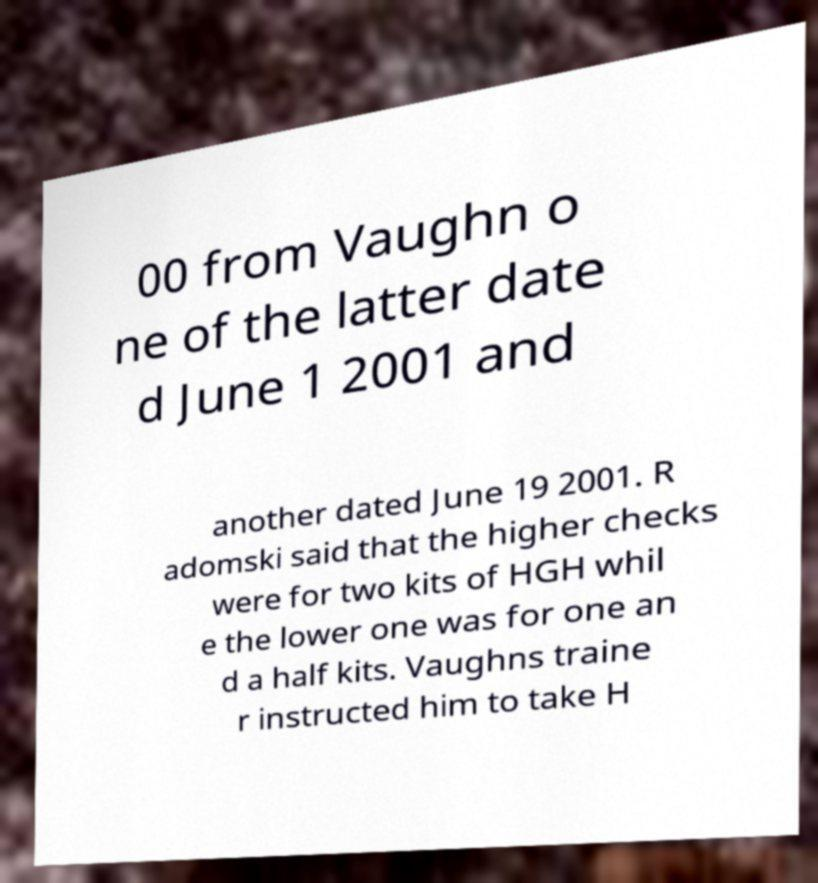I need the written content from this picture converted into text. Can you do that? 00 from Vaughn o ne of the latter date d June 1 2001 and another dated June 19 2001. R adomski said that the higher checks were for two kits of HGH whil e the lower one was for one an d a half kits. Vaughns traine r instructed him to take H 